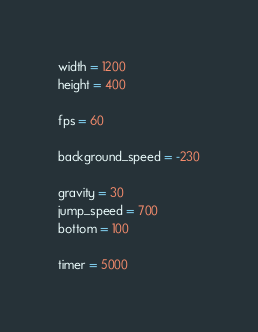Convert code to text. <code><loc_0><loc_0><loc_500><loc_500><_Python_>width = 1200
height = 400

fps = 60

background_speed = -230

gravity = 30
jump_speed = 700
bottom = 100

timer = 5000</code> 